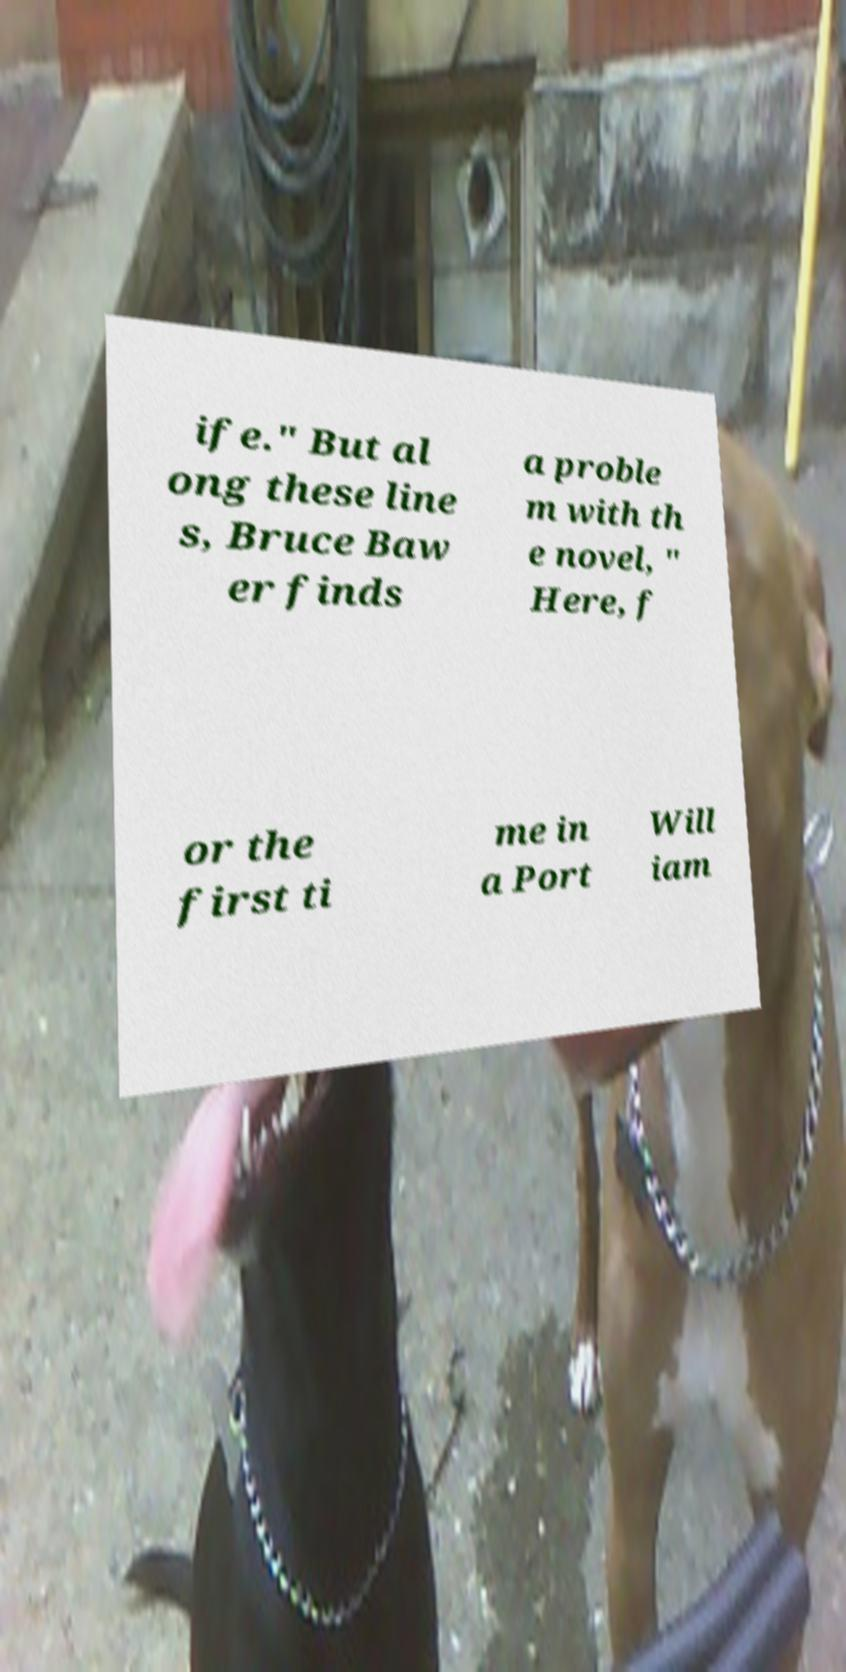Please identify and transcribe the text found in this image. ife." But al ong these line s, Bruce Baw er finds a proble m with th e novel, " Here, f or the first ti me in a Port Will iam 